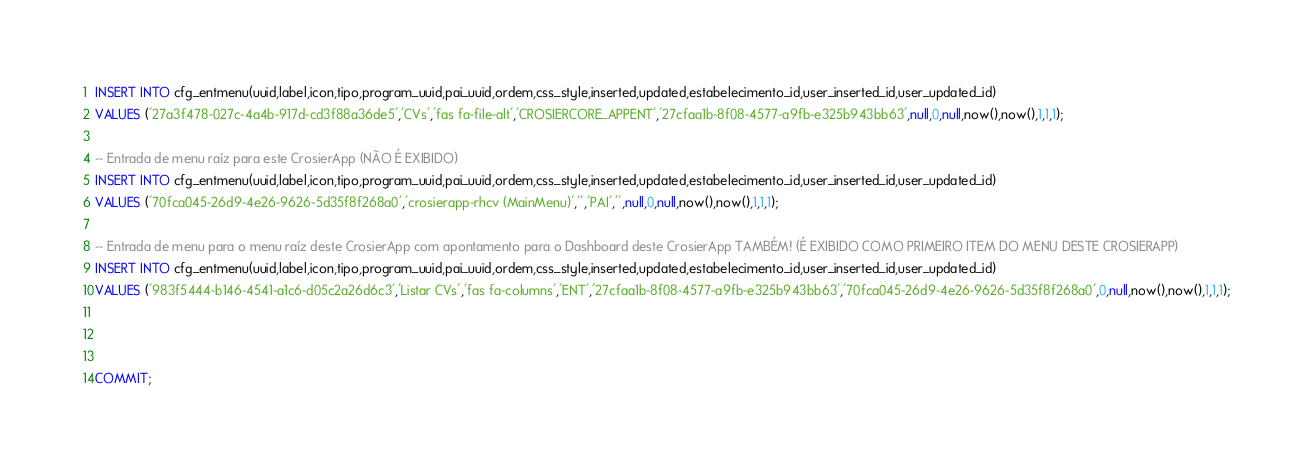<code> <loc_0><loc_0><loc_500><loc_500><_SQL_>INSERT INTO cfg_entmenu(uuid,label,icon,tipo,program_uuid,pai_uuid,ordem,css_style,inserted,updated,estabelecimento_id,user_inserted_id,user_updated_id)
VALUES ('27a3f478-027c-4a4b-917d-cd3f88a36de5','CVs','fas fa-file-alt','CROSIERCORE_APPENT','27cfaa1b-8f08-4577-a9fb-e325b943bb63',null,0,null,now(),now(),1,1,1);

-- Entrada de menu raíz para este CrosierApp (NÃO É EXIBIDO)
INSERT INTO cfg_entmenu(uuid,label,icon,tipo,program_uuid,pai_uuid,ordem,css_style,inserted,updated,estabelecimento_id,user_inserted_id,user_updated_id)
VALUES ('70fca045-26d9-4e26-9626-5d35f8f268a0','crosierapp-rhcv (MainMenu)','','PAI','',null,0,null,now(),now(),1,1,1);

-- Entrada de menu para o menu raíz deste CrosierApp com apontamento para o Dashboard deste CrosierApp TAMBÉM! (É EXIBIDO COMO PRIMEIRO ITEM DO MENU DESTE CROSIERAPP)
INSERT INTO cfg_entmenu(uuid,label,icon,tipo,program_uuid,pai_uuid,ordem,css_style,inserted,updated,estabelecimento_id,user_inserted_id,user_updated_id)
VALUES ('983f5444-b146-4541-a1c6-d05c2a26d6c3','Listar CVs','fas fa-columns','ENT','27cfaa1b-8f08-4577-a9fb-e325b943bb63','70fca045-26d9-4e26-9626-5d35f8f268a0',0,null,now(),now(),1,1,1);



COMMIT;
</code> 